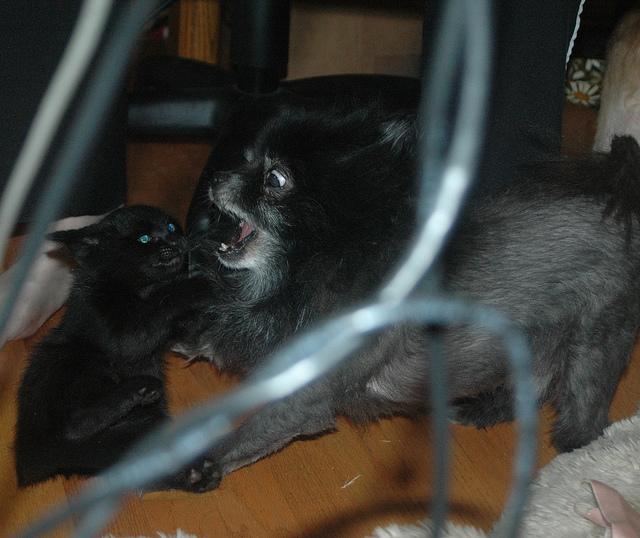What color are the cats feet?
Quick response, please. Black. How many pets can be seen?
Give a very brief answer. 2. Are these cats?
Concise answer only. Yes. Are the animals being hostile?
Be succinct. Yes. 